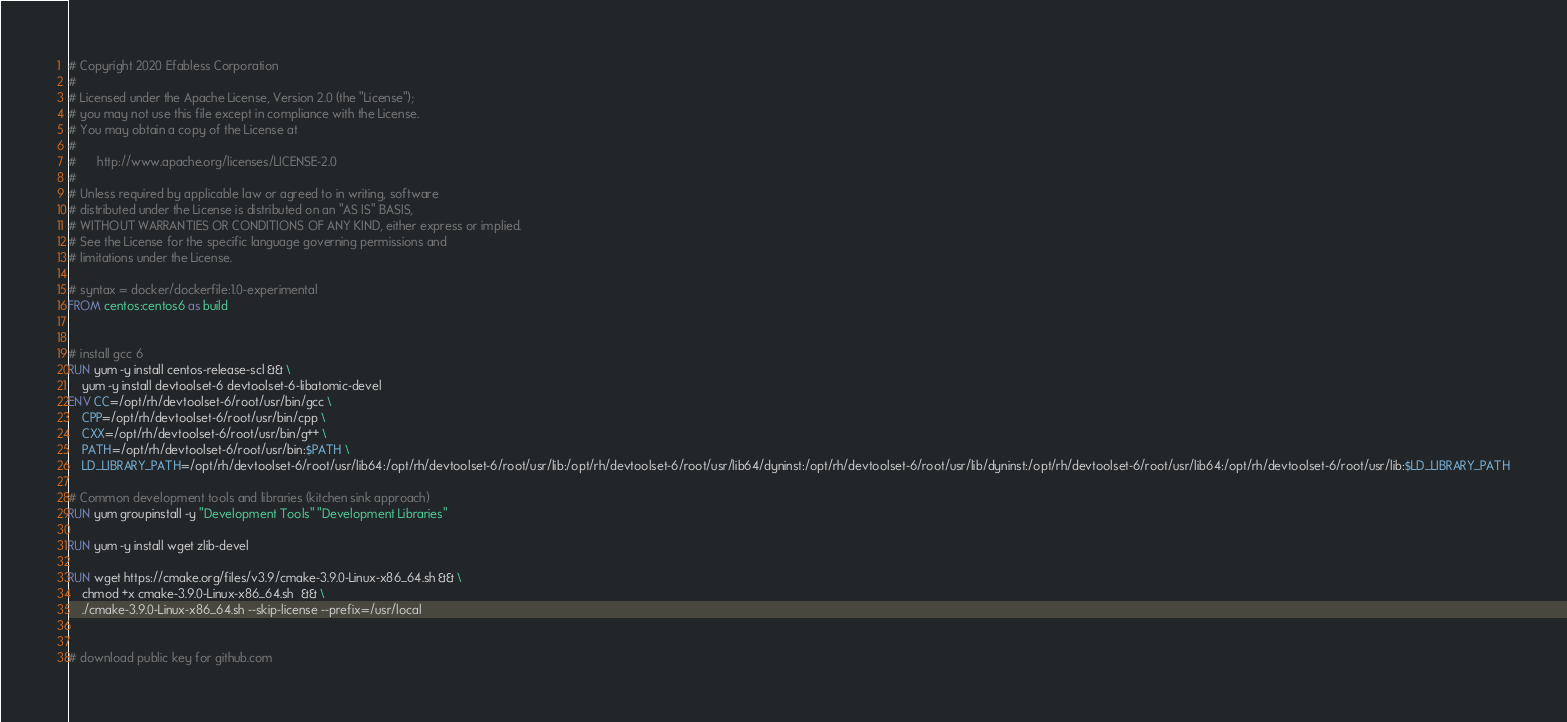<code> <loc_0><loc_0><loc_500><loc_500><_Dockerfile_># Copyright 2020 Efabless Corporation
#
# Licensed under the Apache License, Version 2.0 (the "License");
# you may not use this file except in compliance with the License.
# You may obtain a copy of the License at
#
#      http://www.apache.org/licenses/LICENSE-2.0
#
# Unless required by applicable law or agreed to in writing, software
# distributed under the License is distributed on an "AS IS" BASIS,
# WITHOUT WARRANTIES OR CONDITIONS OF ANY KIND, either express or implied.
# See the License for the specific language governing permissions and
# limitations under the License.

# syntax = docker/dockerfile:1.0-experimental
FROM centos:centos6 as build


# install gcc 6
RUN yum -y install centos-release-scl && \
    yum -y install devtoolset-6 devtoolset-6-libatomic-devel
ENV CC=/opt/rh/devtoolset-6/root/usr/bin/gcc \
    CPP=/opt/rh/devtoolset-6/root/usr/bin/cpp \
    CXX=/opt/rh/devtoolset-6/root/usr/bin/g++ \
    PATH=/opt/rh/devtoolset-6/root/usr/bin:$PATH \
    LD_LIBRARY_PATH=/opt/rh/devtoolset-6/root/usr/lib64:/opt/rh/devtoolset-6/root/usr/lib:/opt/rh/devtoolset-6/root/usr/lib64/dyninst:/opt/rh/devtoolset-6/root/usr/lib/dyninst:/opt/rh/devtoolset-6/root/usr/lib64:/opt/rh/devtoolset-6/root/usr/lib:$LD_LIBRARY_PATH

# Common development tools and libraries (kitchen sink approach)
RUN yum groupinstall -y "Development Tools" "Development Libraries"

RUN yum -y install wget zlib-devel

RUN wget https://cmake.org/files/v3.9/cmake-3.9.0-Linux-x86_64.sh && \
    chmod +x cmake-3.9.0-Linux-x86_64.sh  && \
    ./cmake-3.9.0-Linux-x86_64.sh --skip-license --prefix=/usr/local


# download public key for github.com</code> 